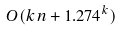<formula> <loc_0><loc_0><loc_500><loc_500>O ( k n + 1 . 2 7 4 ^ { k } )</formula> 